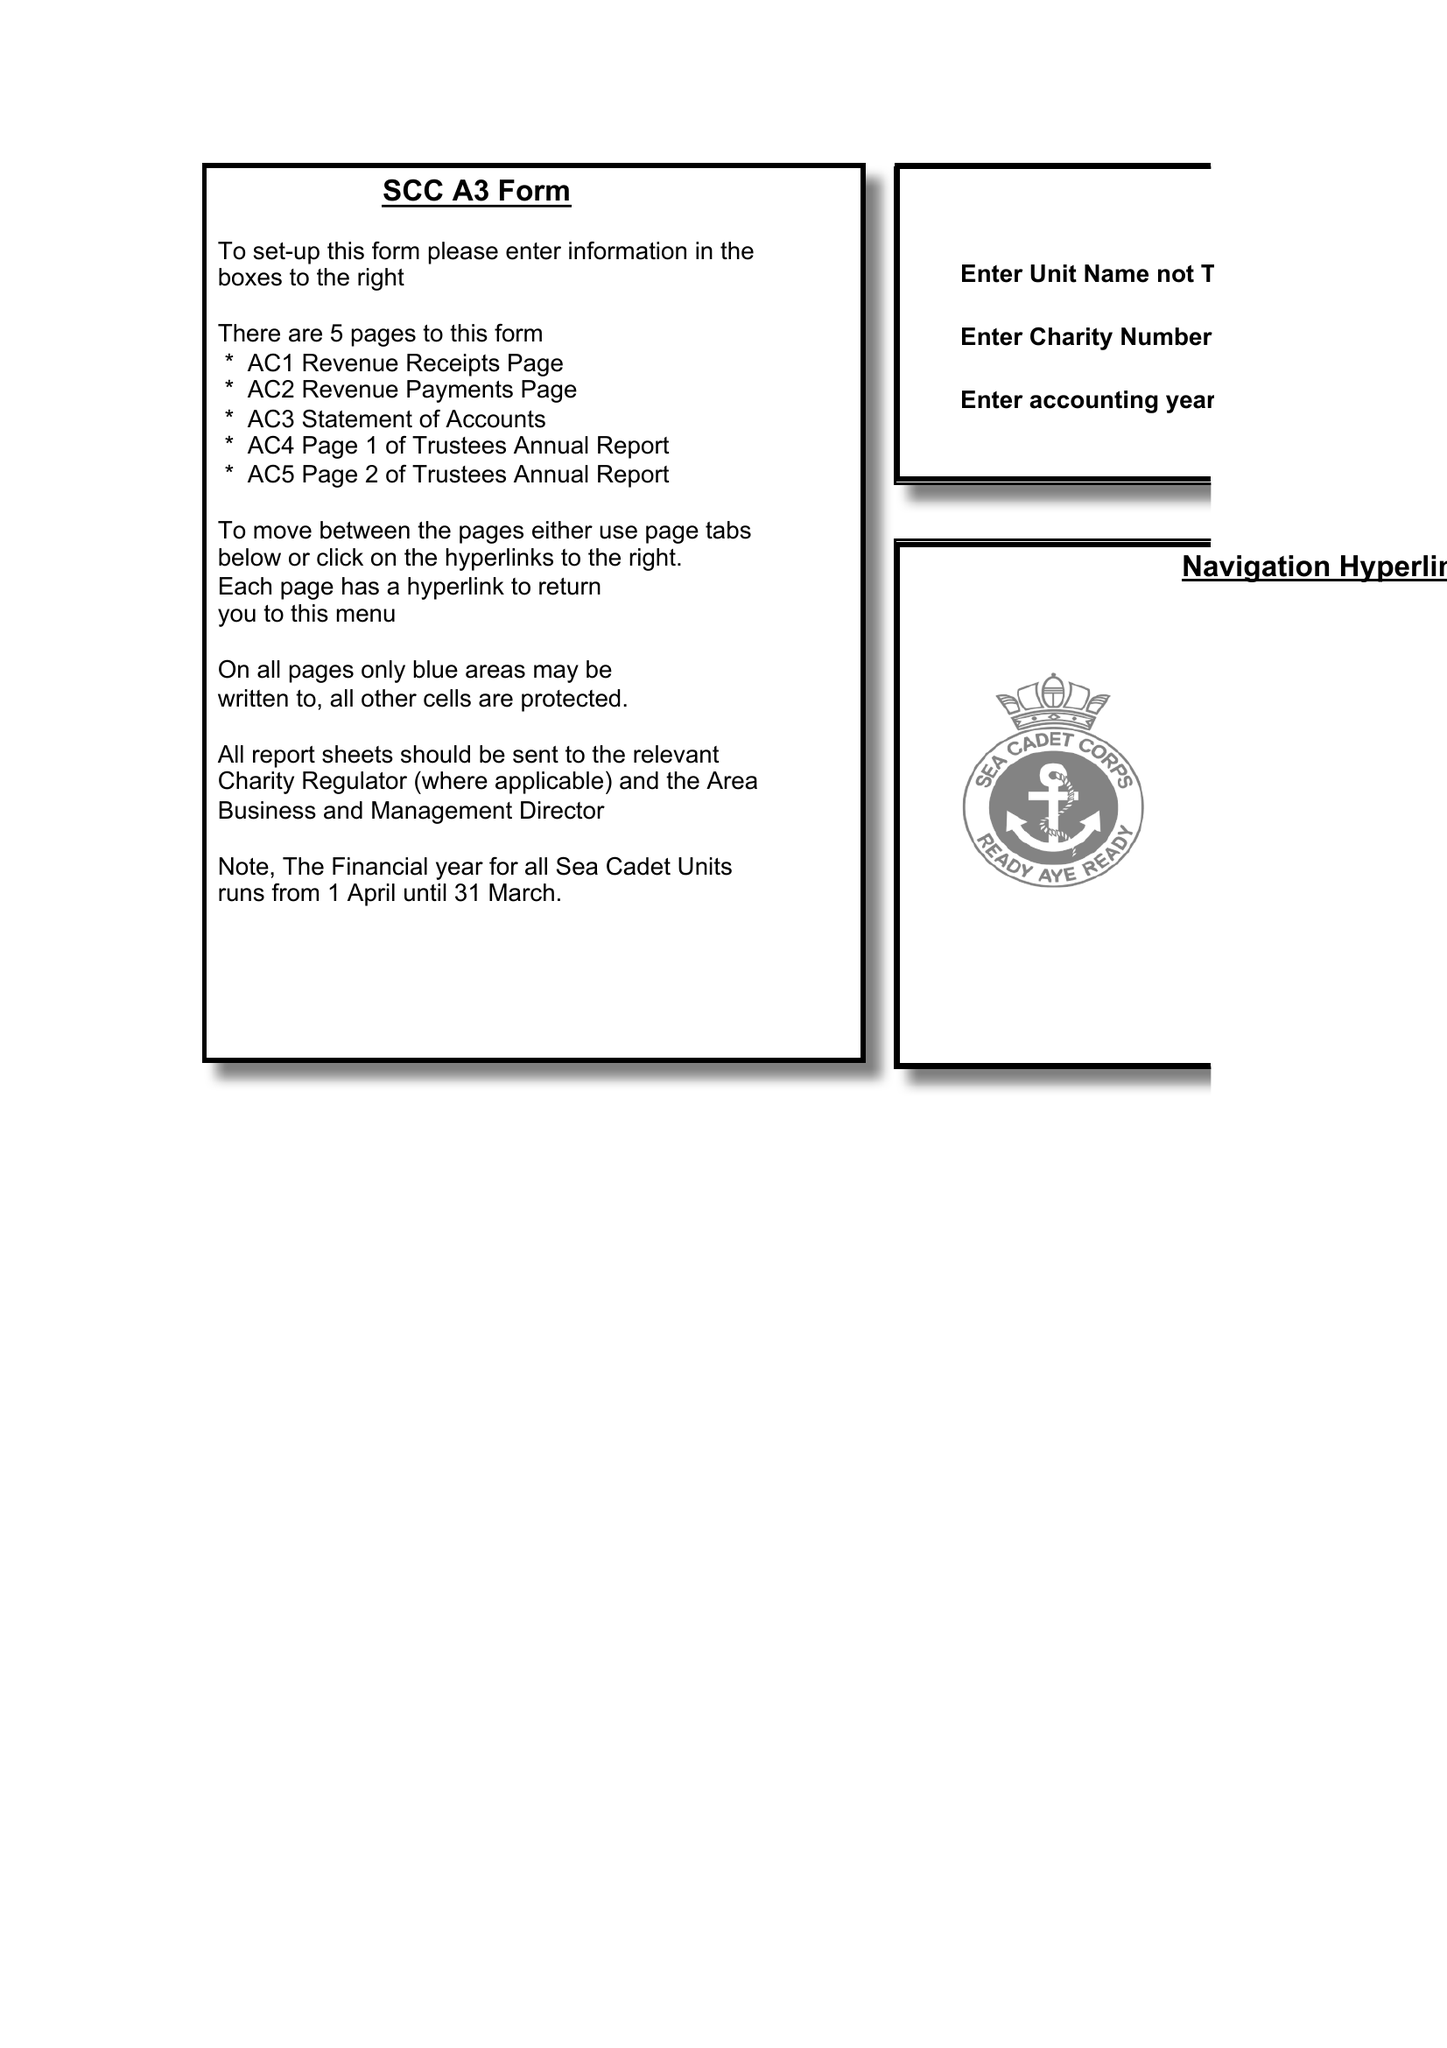What is the value for the charity_number?
Answer the question using a single word or phrase. 524225 